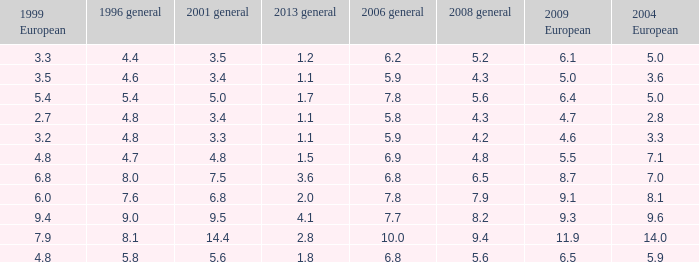What is the average value for general 2001 with more than 4.8 in 1999 European, 7.7 in 2006 general, and more than 9 in 1996 general? None. 